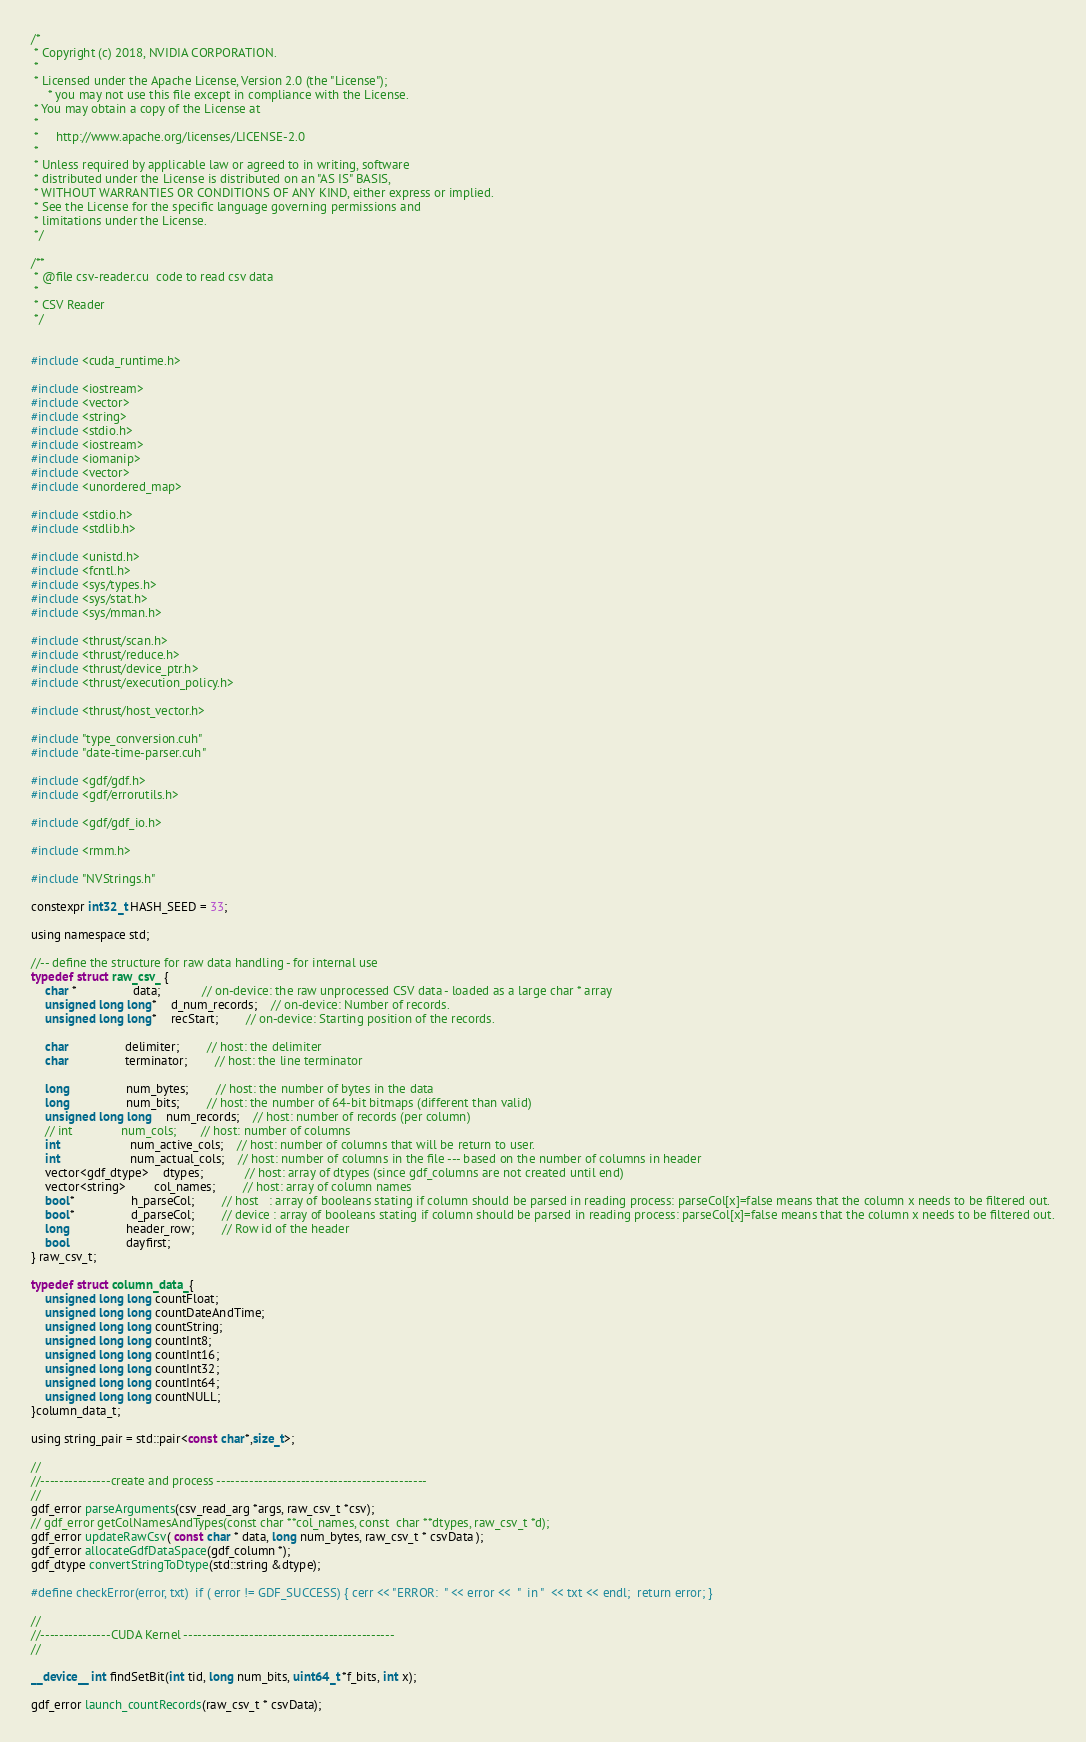<code> <loc_0><loc_0><loc_500><loc_500><_Cuda_>/*
 * Copyright (c) 2018, NVIDIA CORPORATION.
 *
 * Licensed under the Apache License, Version 2.0 (the "License");
	 * you may not use this file except in compliance with the License.
 * You may obtain a copy of the License at
 *
 *     http://www.apache.org/licenses/LICENSE-2.0
 *
 * Unless required by applicable law or agreed to in writing, software
 * distributed under the License is distributed on an "AS IS" BASIS,
 * WITHOUT WARRANTIES OR CONDITIONS OF ANY KIND, either express or implied.
 * See the License for the specific language governing permissions and
 * limitations under the License.
 */

/**
 * @file csv-reader.cu  code to read csv data
 *
 * CSV Reader
 */


#include <cuda_runtime.h>

#include <iostream>
#include <vector>
#include <string>
#include <stdio.h>
#include <iostream>
#include <iomanip>
#include <vector>
#include <unordered_map>

#include <stdio.h>
#include <stdlib.h>

#include <unistd.h>
#include <fcntl.h>
#include <sys/types.h>
#include <sys/stat.h>
#include <sys/mman.h>

#include <thrust/scan.h>
#include <thrust/reduce.h>
#include <thrust/device_ptr.h>
#include <thrust/execution_policy.h>

#include <thrust/host_vector.h>

#include "type_conversion.cuh"
#include "date-time-parser.cuh"

#include <gdf/gdf.h>
#include <gdf/errorutils.h>
 
#include <gdf/gdf_io.h>

#include <rmm.h>

#include "NVStrings.h"

constexpr int32_t HASH_SEED = 33;

using namespace std;

//-- define the structure for raw data handling - for internal use
typedef struct raw_csv_ {
    char *				data;			// on-device: the raw unprocessed CSV data - loaded as a large char * array
    unsigned long long*	d_num_records;	// on-device: Number of records.
    unsigned long long*	recStart;		// on-device: Starting position of the records.

    char				delimiter;		// host: the delimiter
    char				terminator;		// host: the line terminator

    long				num_bytes;		// host: the number of bytes in the data
    long				num_bits;		// host: the number of 64-bit bitmaps (different than valid)
	unsigned long long 	num_records;  	// host: number of records (per column)
	// int				num_cols;		// host: number of columns
	int					num_active_cols;	// host: number of columns that will be return to user.
	int					num_actual_cols;	// host: number of columns in the file --- based on the number of columns in header
    vector<gdf_dtype>	dtypes;			// host: array of dtypes (since gdf_columns are not created until end)
    vector<string>		col_names;		// host: array of column names
    bool* 				h_parseCol;		// host   : array of booleans stating if column should be parsed in reading process: parseCol[x]=false means that the column x needs to be filtered out.
    bool* 				d_parseCol;		// device : array of booleans stating if column should be parsed in reading process: parseCol[x]=false means that the column x needs to be filtered out.
    long 				header_row;		// Row id of the header
    bool				dayfirst;
} raw_csv_t;

typedef struct column_data_{
	unsigned long long countFloat;
	unsigned long long countDateAndTime;
	unsigned long long countString;
	unsigned long long countInt8;
	unsigned long long countInt16;
	unsigned long long countInt32;
	unsigned long long countInt64;	
	unsigned long long countNULL;
}column_data_t;

using string_pair = std::pair<const char*,size_t>;

//
//---------------create and process ---------------------------------------------
//
gdf_error parseArguments(csv_read_arg *args, raw_csv_t *csv);
// gdf_error getColNamesAndTypes(const char **col_names, const  char **dtypes, raw_csv_t *d);
gdf_error updateRawCsv( const char * data, long num_bytes, raw_csv_t * csvData );
gdf_error allocateGdfDataSpace(gdf_column *);
gdf_dtype convertStringToDtype(std::string &dtype);

#define checkError(error, txt)  if ( error != GDF_SUCCESS) { cerr << "ERROR:  " << error <<  "  in "  << txt << endl;  return error; }

//
//---------------CUDA Kernel ---------------------------------------------
//

__device__ int findSetBit(int tid, long num_bits, uint64_t *f_bits, int x);

gdf_error launch_countRecords(raw_csv_t * csvData);</code> 